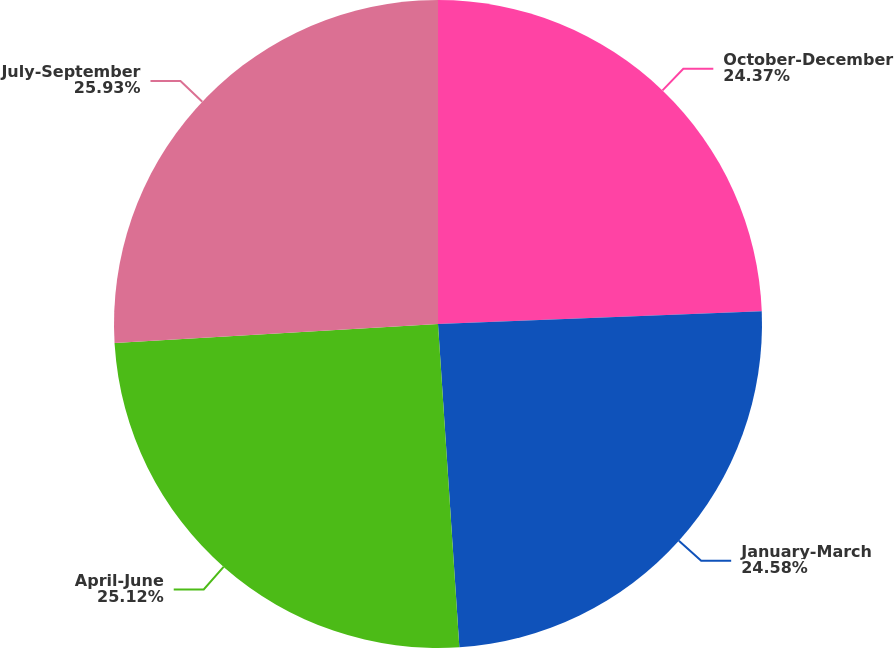Convert chart. <chart><loc_0><loc_0><loc_500><loc_500><pie_chart><fcel>October-December<fcel>January-March<fcel>April-June<fcel>July-September<nl><fcel>24.37%<fcel>24.58%<fcel>25.12%<fcel>25.93%<nl></chart> 